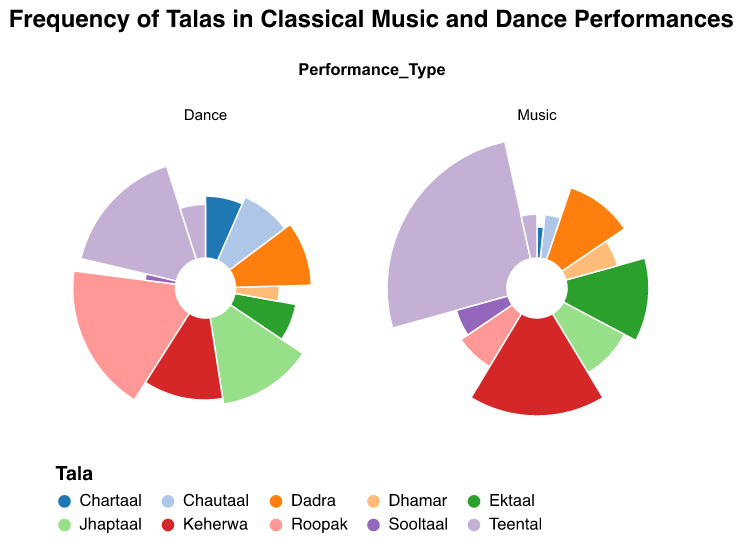What is the title of the figure? The title is usually displayed at the top of the figure, and it describes the content of the chart. This title often helps in understanding the overall theme of the data presented.
Answer: Frequency of Talas in Classical Music and Dance Performances How many different Talas are represented in the figure? The Talas are differentiated by the colors in the polar chart and listed in the legend. Counting all unique Tala names will give the total number.
Answer: 10 Which Tala is most frequently performed in Concerts for both Music and Dance? By observing the size of the arcs in the Concert section for both Music and Dance, the one with the largest combined size can be identified as the most frequent one.
Answer: Teental What is the combined frequency of Teental in Music performances across all events? Sum up the frequencies of Teental in all Music performance events from the chart: Concert (15) + Devotional Event (2).
Answer: 17 Which Tala has the smallest total frequency in Dance performances? By comparing the size of the arcs in the Dance section, the Tala with the smallest combined arc across all Dance performance events can be identified.
Answer: Sooltaal How does the frequency of Roopak differ between Music and Dance performances? Find the frequency of Roopak in the Music section (Concert) and in the Dance section (Stage Show), and subtract one value from the other.
Answer: 7 Compare the frequency of Keherwa in Devotional Events between Music and Dance performances. Check the frequencies of Keherwa in the Devotional Event segment for both Music and Dance, and compare them directly.
Answer: Music has 10, Dance has 0 Which performance type shows a higher overall frequency of Jhaptaal? Sum the frequencies of Jhaptaal in all Music events and all Dance events, then compare the two sums.
Answer: Dance What are the events where Chautaal is used in Music performances? Look in the Music section of the chart for Chautaal, and identify the corresponding events in the tooltip or legend.
Answer: Concert How many times is Dadra performed in total across all events and performance types? Sum the frequencies of Dadra across all listed events in both Music and Dance sections.
Answer: 12 